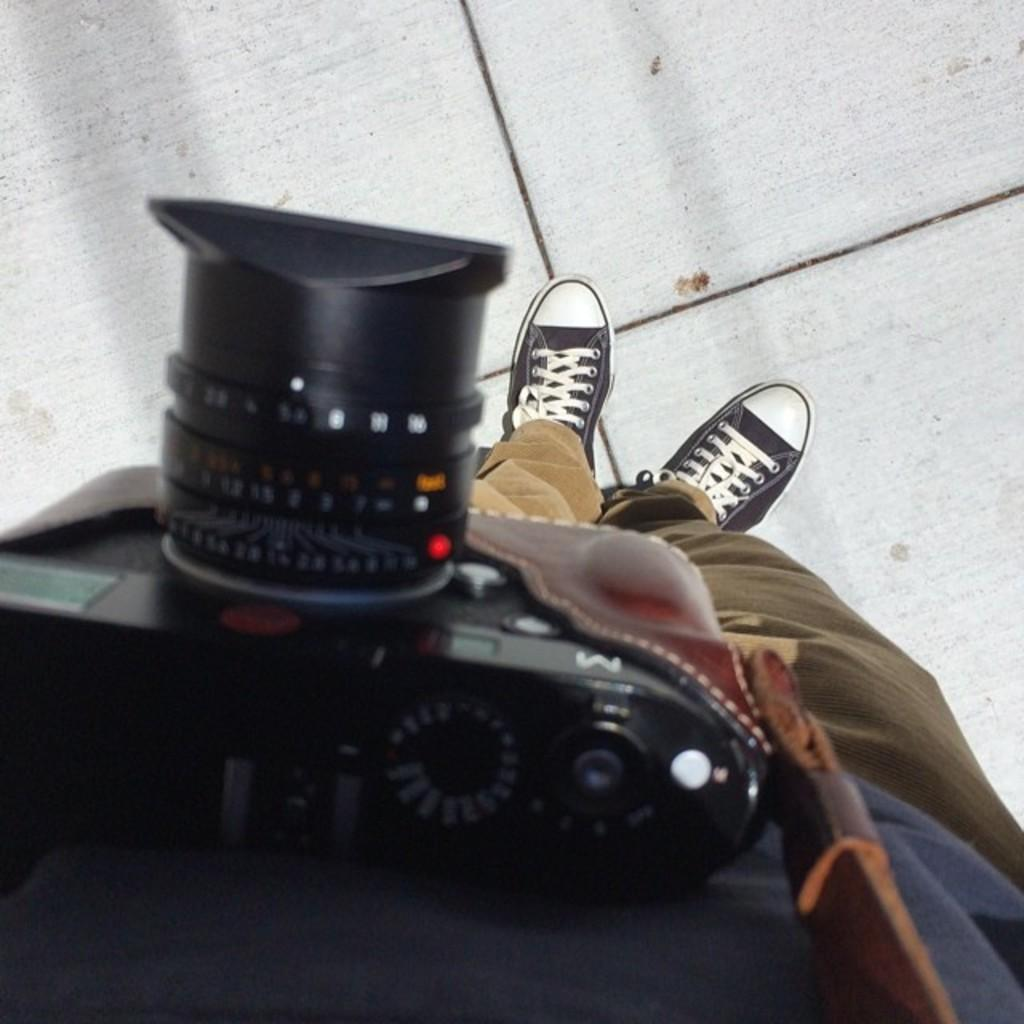What is the person in the image doing? The person is standing on a surface. What object is the person holding in the image? The person is holding a camera. How is the camera being carried or secured in the image? The camera is attached to a belt. What type of texture can be seen on the person's clothing in the image? There is no information provided about the texture of the person's clothing in the image. How many men are present in the image? The provided facts do not mention the gender of the person in the image, so it cannot be determined if the person is a man or not. 